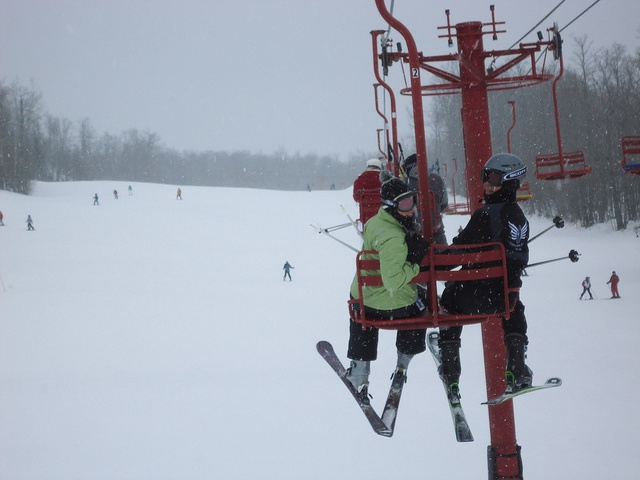Describe the objects in this image and their specific colors. I can see people in darkgray, black, gray, and maroon tones, people in darkgray, black, gray, and lightgray tones, skis in darkgray, gray, and black tones, people in darkgray, black, gray, and maroon tones, and people in darkgray, maroon, gray, and brown tones in this image. 